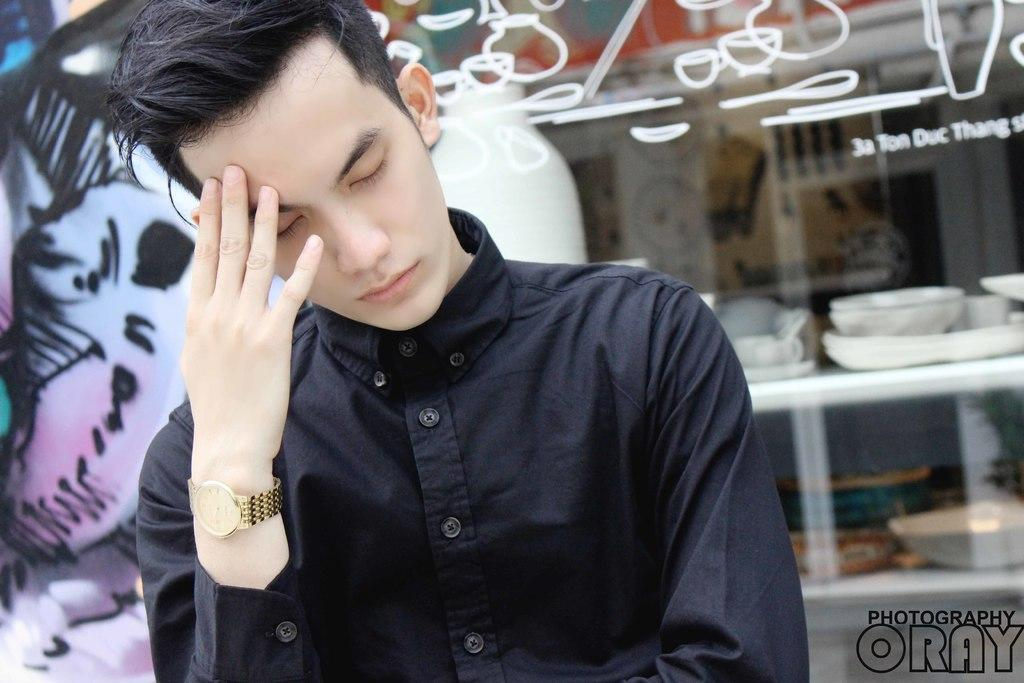What can be seen in the image? There is a person in the image. What is the person wearing? The person is wearing a black shirt and a gold color watch. How would you describe the background of the image? The background of the image is blurred. Is there any text visible in the image? Yes, there is some text in the bottom right corner of the image. What type of toys can be seen in the image? There are no toys present in the image. Is there a baseball game happening in the background of the image? There is no baseball game visible in the image; the background is blurred. 